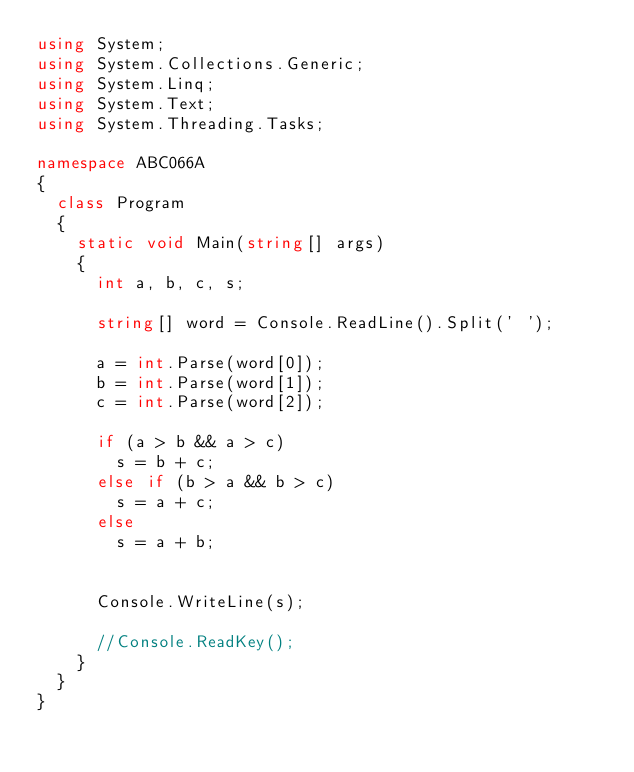Convert code to text. <code><loc_0><loc_0><loc_500><loc_500><_C#_>using System;
using System.Collections.Generic;
using System.Linq;
using System.Text;
using System.Threading.Tasks;

namespace ABC066A
{
	class Program
	{
		static void Main(string[] args)
		{
			int a, b, c, s;

			string[] word = Console.ReadLine().Split(' ');

			a = int.Parse(word[0]);
			b = int.Parse(word[1]);
			c = int.Parse(word[2]);

			if (a > b && a > c)
				s = b + c;
			else if (b > a && b > c)
				s = a + c;
			else
				s = a + b;


			Console.WriteLine(s);

			//Console.ReadKey();
		}
	}
}
</code> 